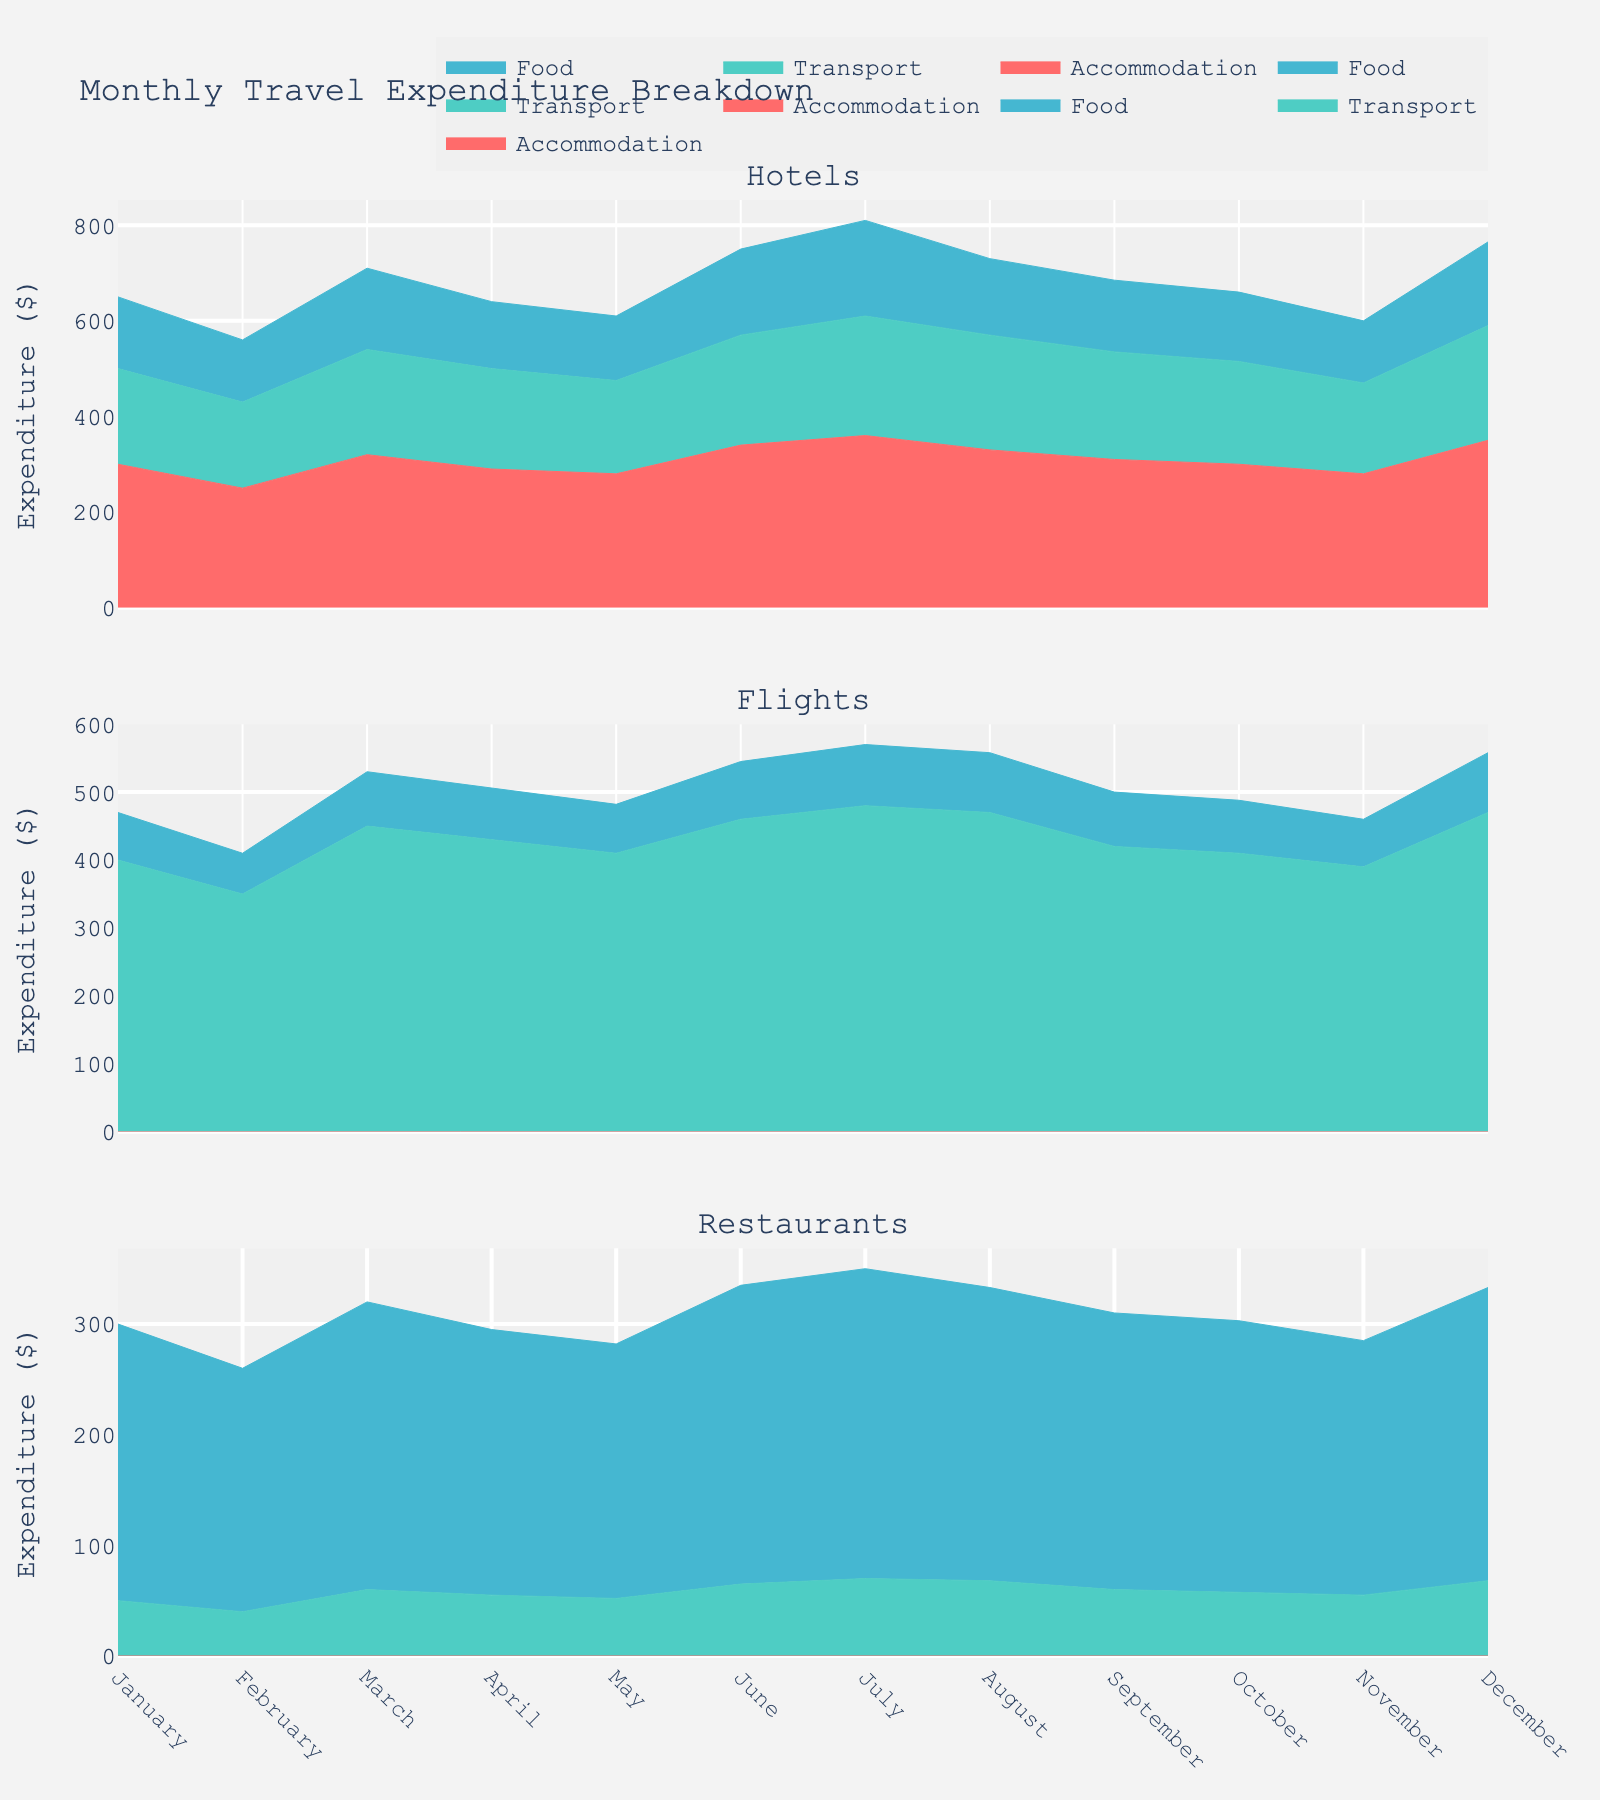What's the title of the figure? The title of the figure is typically displayed at the top of the chart. Observing it shows "Monthly Travel Expenditure Breakdown."
Answer: Monthly Travel Expenditure Breakdown How many categories of travel-related activities are there? By examining the subplot titles, you can count the different categories. There are three categories: Hotels, Flights, and Restaurants.
Answer: Three In which month did the accommodation expenditure peak for hotels? To identify this, look at the subplot for Hotels and check the highest point in the Accommodation area. The highest expenditure appears in July.
Answer: July Compare the total expenditure on food in July and November for restaurants. Which is higher? By checking the Food area in the Restaurants subplot, July has a higher peak compared to November.
Answer: July What is the average transportation expenditure for flights in the first quarter? The first quarter includes January, February, and March. The transportation expenditure for Flights in these months is 400, 350, and 450, respectively. The average is calculated as (400 + 350 + 450) / 3 = 400.
Answer: 400 Which category shows the highest monthly expenditure in December? By observing the three subplots for December, Flights have the highest peak value compared to Hotels and Restaurants.
Answer: Flights Which month has the minimal transportation expenditure for hotels? Look at the subplot for Hotels and find the lowest point in the Transport area. February has the lowest transportation expenditure.
Answer: February Is the expenditure on food for restaurants consistently increasing from January to July? Check the Food area in the Restaurants subplot from January to July. The expenditure generally increases over these months, with small variations.
Answer: Yes Summarize the trend of accommodation expenditure for hotels throughout the year. Observing the Accommodation area in the Hotels subplot, expenditure fluctuates but peaks in July and generally increases towards the end of the year.
Answer: Fluctuates, peaks in July What is the total expenditure in March for flights? Sum the values of Accommodation, Transport, and Food for Flights in March. They are 0, 450, and 80, respectively. The total is 0 + 450 + 80 = 530.
Answer: 530 